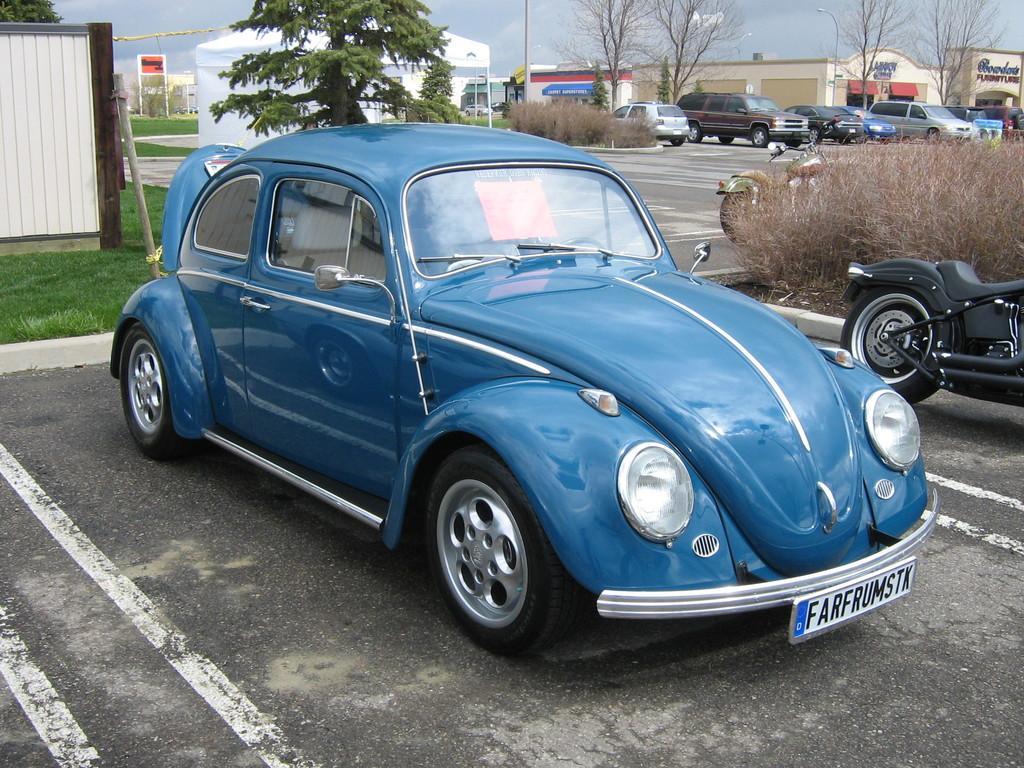In one or two sentences, can you explain what this image depicts? In this image there are vehicles on the road. There are buildings, boards, light poles, trees, poles, plants and a tent. At the top of the image there is sky. 